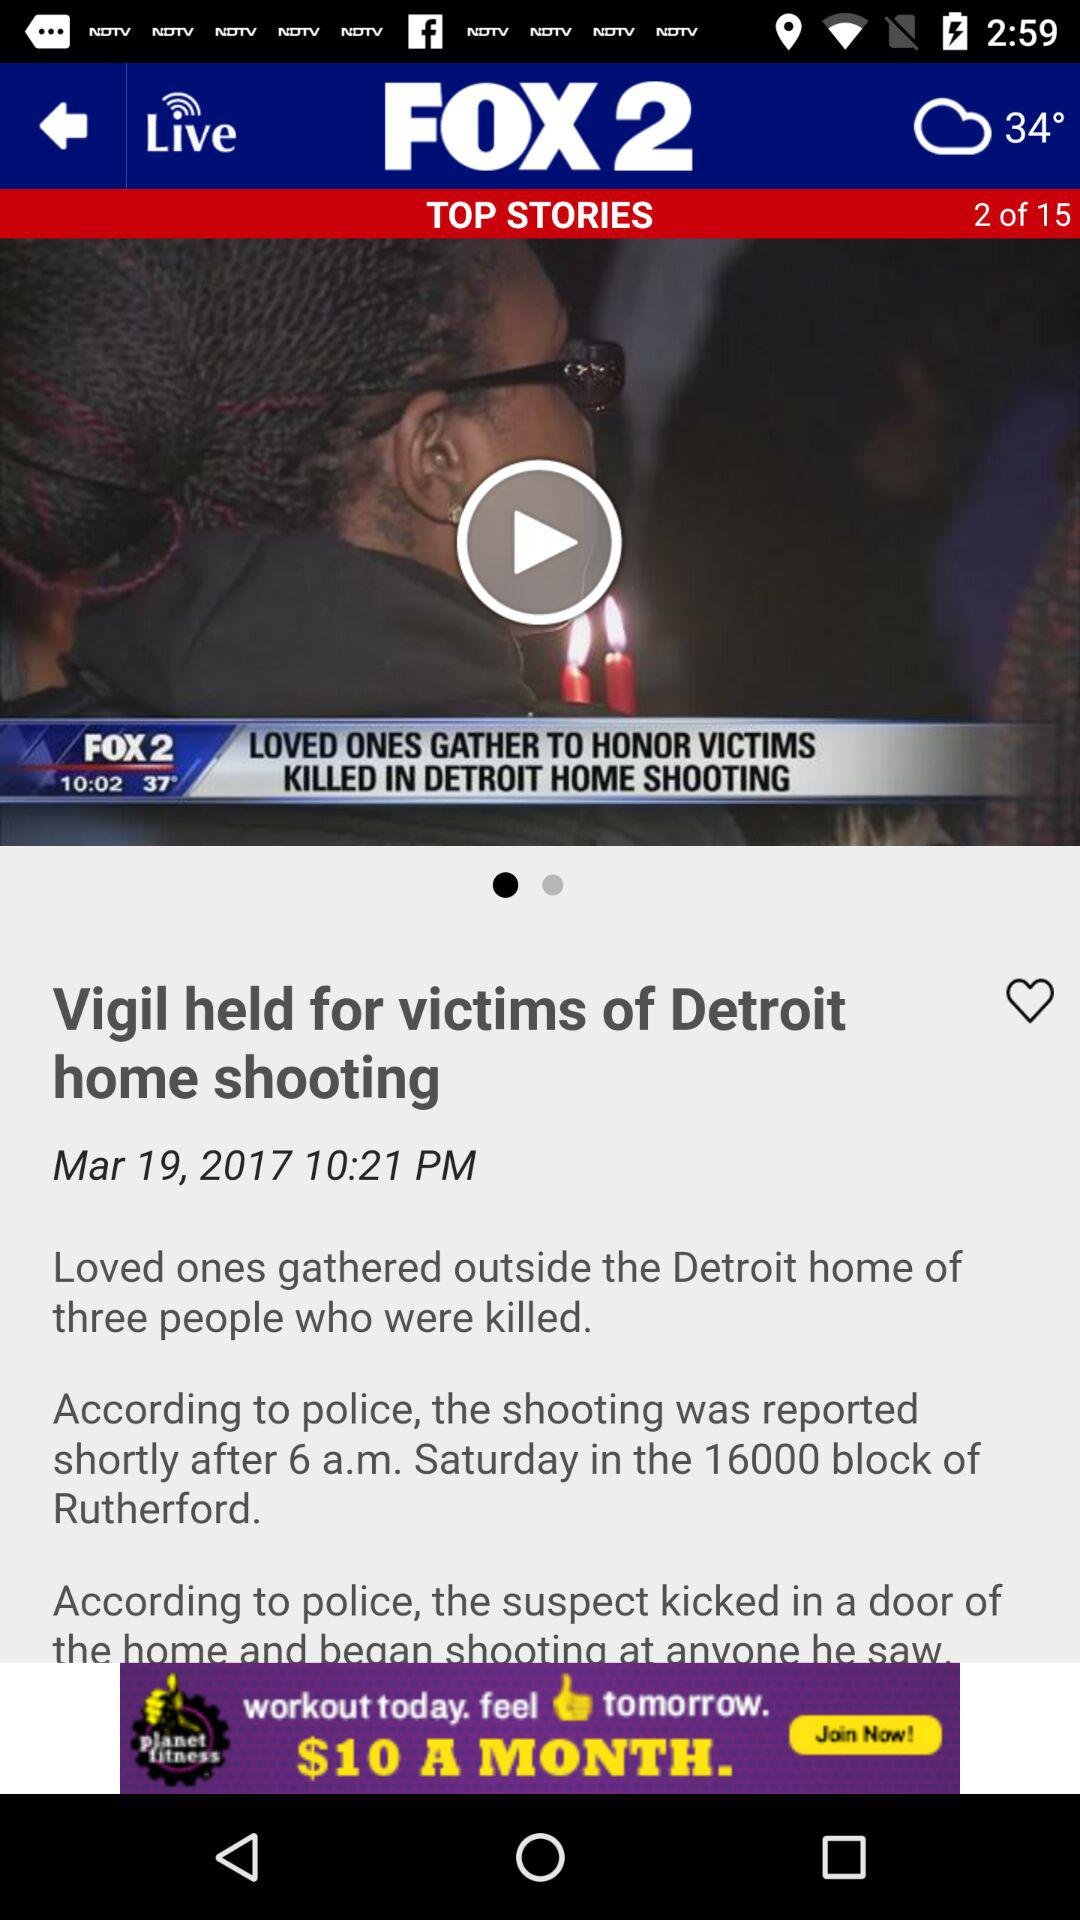What is the total number of pages in the top stories? The total number of pages is 15. 